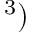<formula> <loc_0><loc_0><loc_500><loc_500>^ { 3 } )</formula> 